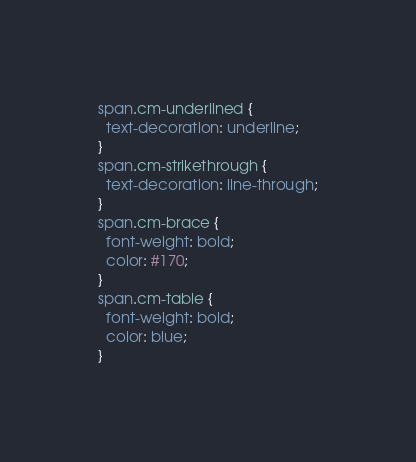Convert code to text. <code><loc_0><loc_0><loc_500><loc_500><_CSS_>span.cm-underlined {
  text-decoration: underline;
}
span.cm-strikethrough {
  text-decoration: line-through;
}
span.cm-brace {
  font-weight: bold;
  color: #170;
}
span.cm-table {
  font-weight: bold;
  color: blue;
}
</code> 